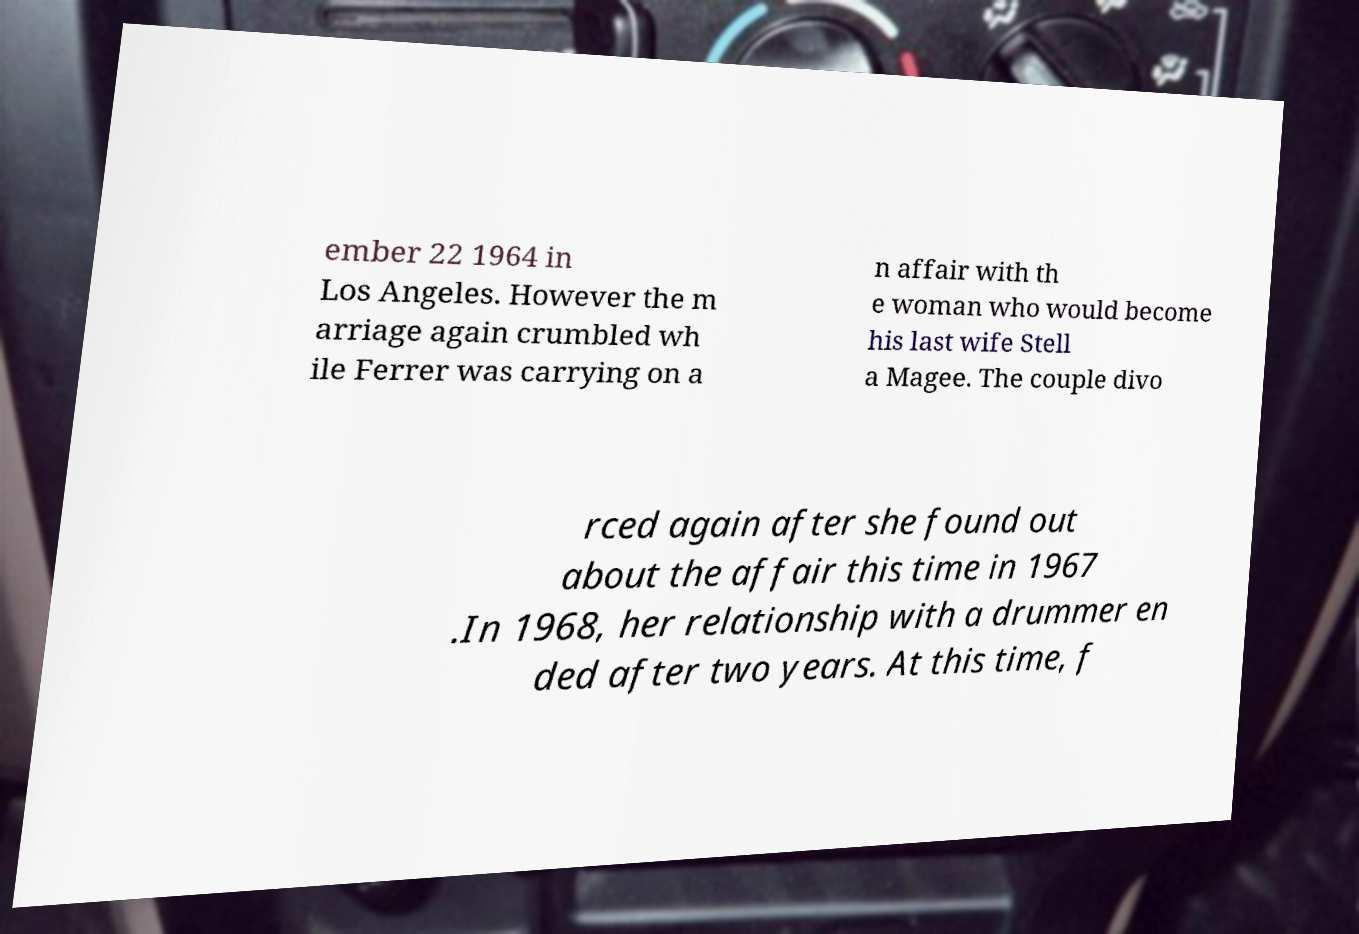Could you assist in decoding the text presented in this image and type it out clearly? ember 22 1964 in Los Angeles. However the m arriage again crumbled wh ile Ferrer was carrying on a n affair with th e woman who would become his last wife Stell a Magee. The couple divo rced again after she found out about the affair this time in 1967 .In 1968, her relationship with a drummer en ded after two years. At this time, f 